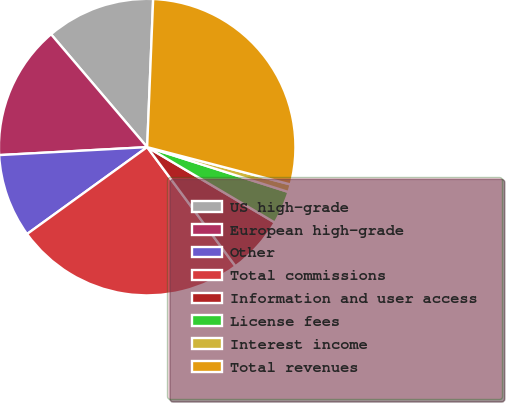<chart> <loc_0><loc_0><loc_500><loc_500><pie_chart><fcel>US high-grade<fcel>European high-grade<fcel>Other<fcel>Total commissions<fcel>Information and user access<fcel>License fees<fcel>Interest income<fcel>Total revenues<nl><fcel>11.87%<fcel>14.63%<fcel>9.11%<fcel>25.19%<fcel>6.35%<fcel>3.6%<fcel>0.84%<fcel>28.41%<nl></chart> 